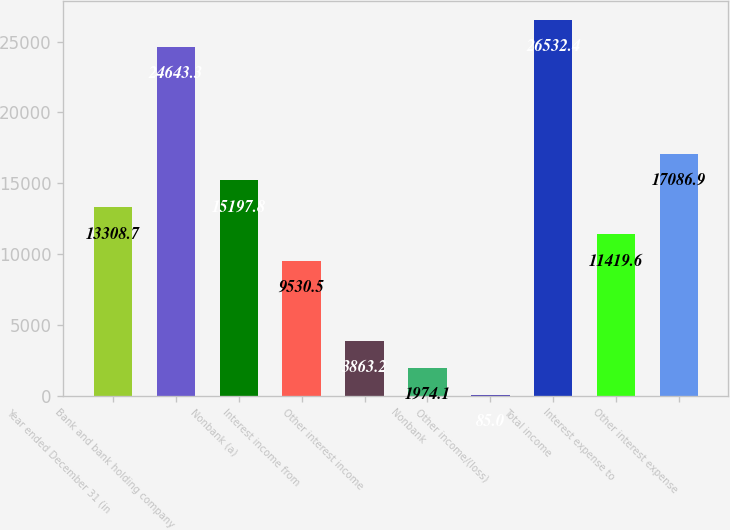Convert chart. <chart><loc_0><loc_0><loc_500><loc_500><bar_chart><fcel>Year ended December 31 (in<fcel>Bank and bank holding company<fcel>Nonbank (a)<fcel>Interest income from<fcel>Other interest income<fcel>Nonbank<fcel>Other income/(loss)<fcel>Total income<fcel>Interest expense to<fcel>Other interest expense<nl><fcel>13308.7<fcel>24643.3<fcel>15197.8<fcel>9530.5<fcel>3863.2<fcel>1974.1<fcel>85<fcel>26532.4<fcel>11419.6<fcel>17086.9<nl></chart> 